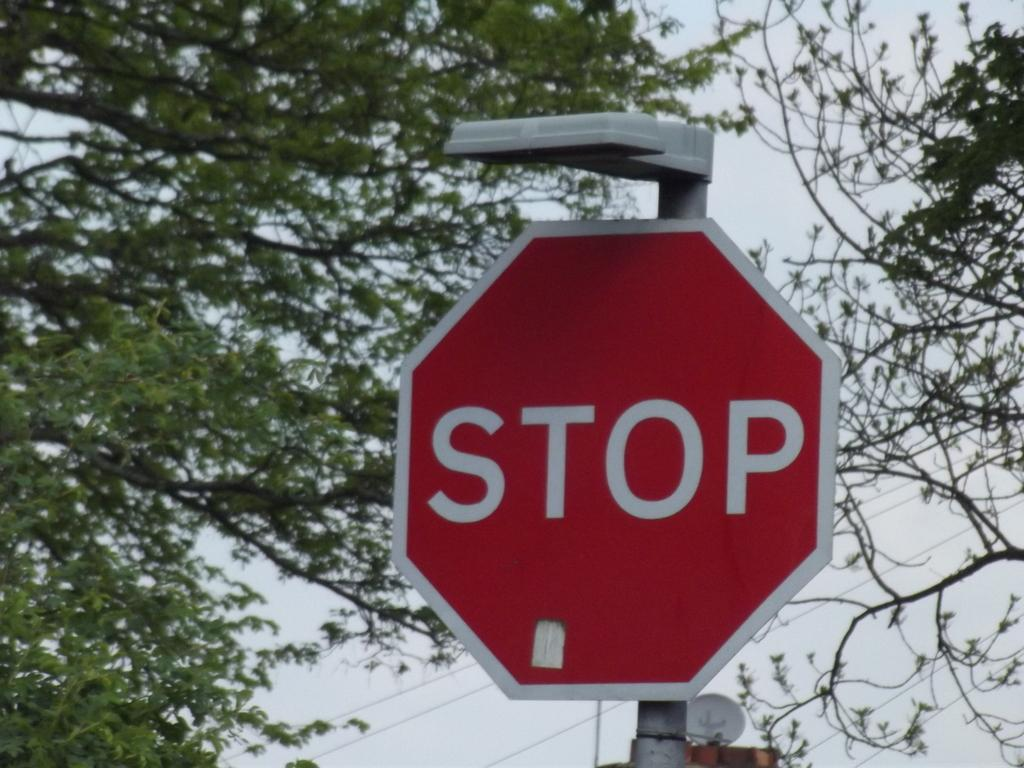<image>
Give a short and clear explanation of the subsequent image. Red stop sigh in front of some trees. 